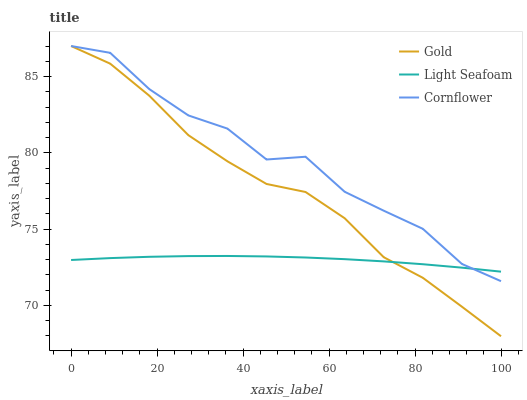Does Light Seafoam have the minimum area under the curve?
Answer yes or no. Yes. Does Cornflower have the maximum area under the curve?
Answer yes or no. Yes. Does Gold have the minimum area under the curve?
Answer yes or no. No. Does Gold have the maximum area under the curve?
Answer yes or no. No. Is Light Seafoam the smoothest?
Answer yes or no. Yes. Is Cornflower the roughest?
Answer yes or no. Yes. Is Gold the smoothest?
Answer yes or no. No. Is Gold the roughest?
Answer yes or no. No. Does Gold have the lowest value?
Answer yes or no. Yes. Does Light Seafoam have the lowest value?
Answer yes or no. No. Does Gold have the highest value?
Answer yes or no. Yes. Does Light Seafoam have the highest value?
Answer yes or no. No. Does Gold intersect Light Seafoam?
Answer yes or no. Yes. Is Gold less than Light Seafoam?
Answer yes or no. No. Is Gold greater than Light Seafoam?
Answer yes or no. No. 